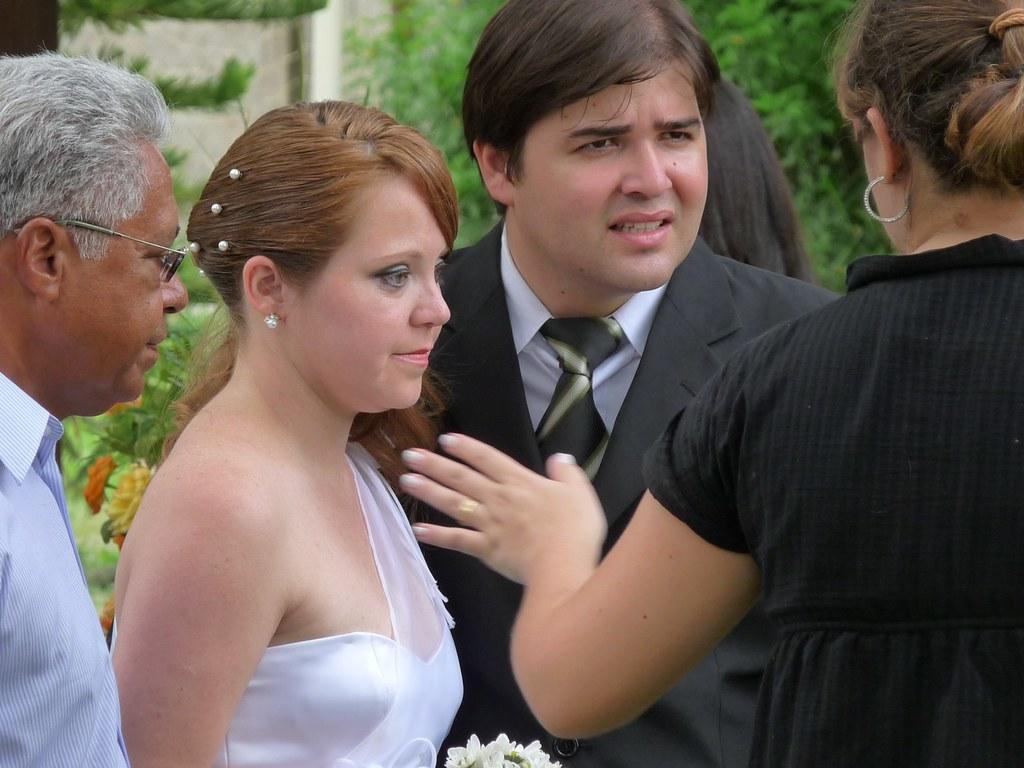Please provide a concise description of this image. In this image we can see two men and women. One man is wearing black color coat and the other one is wearing blue color shirt. Woman is wearing white color dress and the other woman is wearing black color dress. Behind them plants are there. 